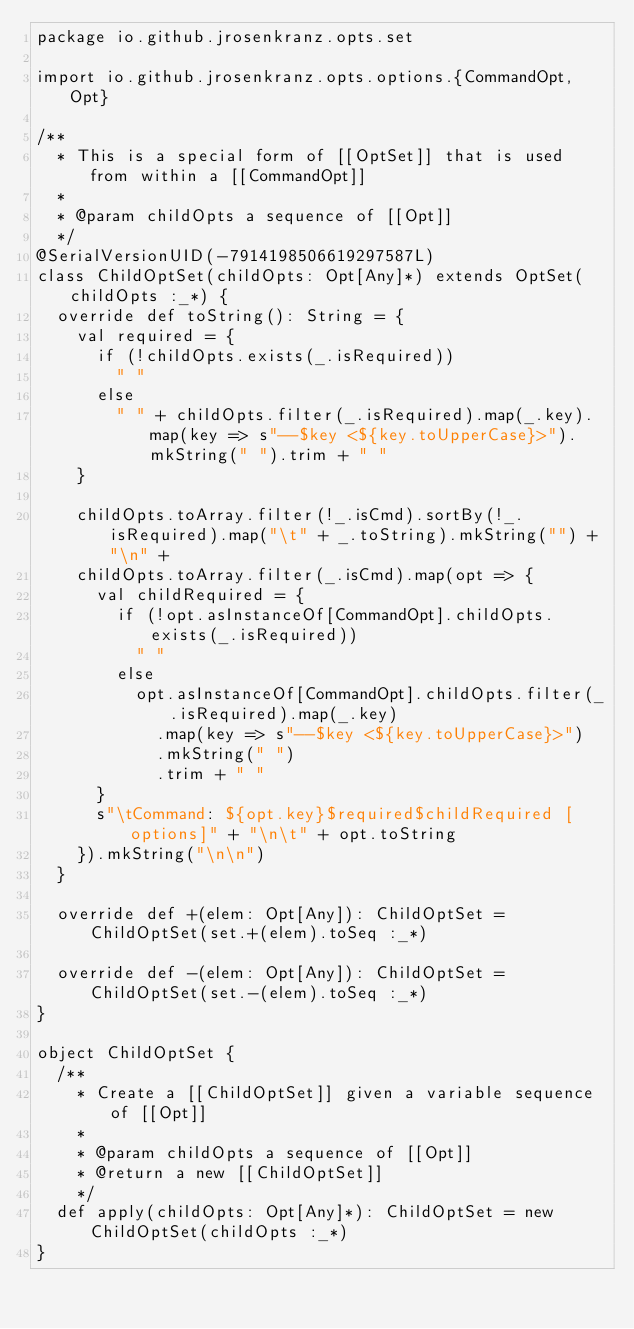Convert code to text. <code><loc_0><loc_0><loc_500><loc_500><_Scala_>package io.github.jrosenkranz.opts.set

import io.github.jrosenkranz.opts.options.{CommandOpt, Opt}

/**
  * This is a special form of [[OptSet]] that is used from within a [[CommandOpt]]
  *
  * @param childOpts a sequence of [[Opt]]
  */
@SerialVersionUID(-7914198506619297587L)
class ChildOptSet(childOpts: Opt[Any]*) extends OptSet(childOpts :_*) {
  override def toString(): String = {
    val required = {
      if (!childOpts.exists(_.isRequired))
        " "
      else
        " " + childOpts.filter(_.isRequired).map(_.key).map(key => s"--$key <${key.toUpperCase}>").mkString(" ").trim + " "
    }

    childOpts.toArray.filter(!_.isCmd).sortBy(!_.isRequired).map("\t" + _.toString).mkString("") + "\n" +
    childOpts.toArray.filter(_.isCmd).map(opt => {
      val childRequired = {
        if (!opt.asInstanceOf[CommandOpt].childOpts.exists(_.isRequired))
          " "
        else
          opt.asInstanceOf[CommandOpt].childOpts.filter(_.isRequired).map(_.key)
            .map(key => s"--$key <${key.toUpperCase}>")
            .mkString(" ")
            .trim + " "
      }
      s"\tCommand: ${opt.key}$required$childRequired [options]" + "\n\t" + opt.toString
    }).mkString("\n\n")
  }

  override def +(elem: Opt[Any]): ChildOptSet = ChildOptSet(set.+(elem).toSeq :_*)

  override def -(elem: Opt[Any]): ChildOptSet = ChildOptSet(set.-(elem).toSeq :_*)
}

object ChildOptSet {
  /**
    * Create a [[ChildOptSet]] given a variable sequence of [[Opt]]
    *
    * @param childOpts a sequence of [[Opt]]
    * @return a new [[ChildOptSet]]
    */
  def apply(childOpts: Opt[Any]*): ChildOptSet = new ChildOptSet(childOpts :_*)
}

</code> 